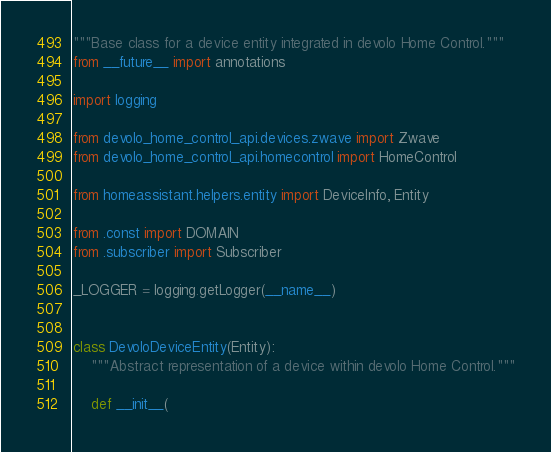<code> <loc_0><loc_0><loc_500><loc_500><_Python_>"""Base class for a device entity integrated in devolo Home Control."""
from __future__ import annotations

import logging

from devolo_home_control_api.devices.zwave import Zwave
from devolo_home_control_api.homecontrol import HomeControl

from homeassistant.helpers.entity import DeviceInfo, Entity

from .const import DOMAIN
from .subscriber import Subscriber

_LOGGER = logging.getLogger(__name__)


class DevoloDeviceEntity(Entity):
    """Abstract representation of a device within devolo Home Control."""

    def __init__(</code> 